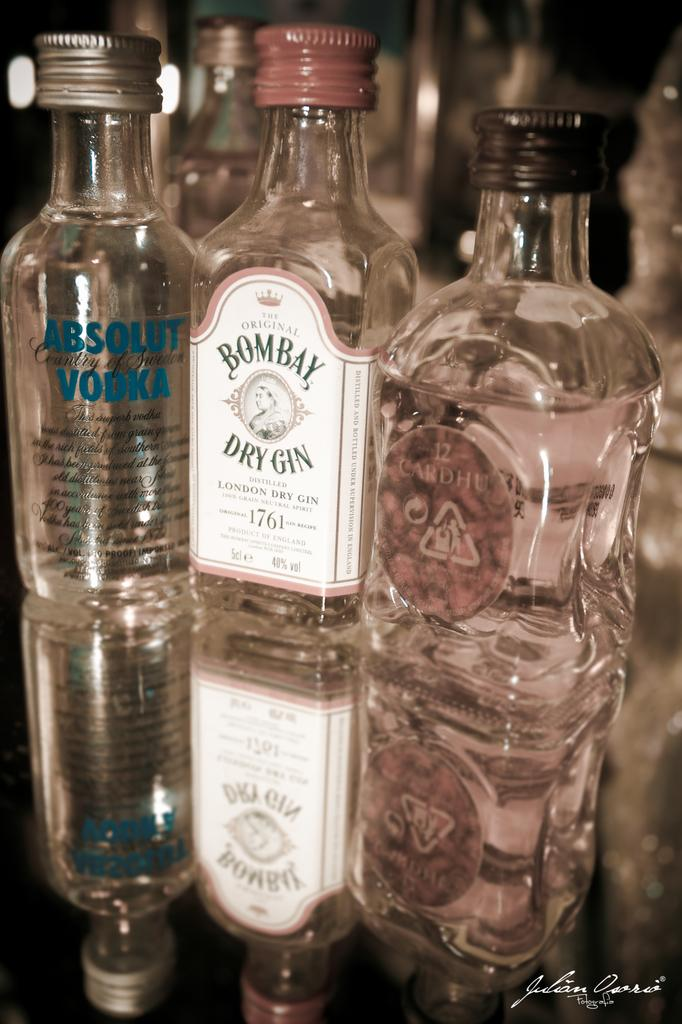<image>
Summarize the visual content of the image. Clear bottle of Bombay dry gin next to some other bottles of vodka. 